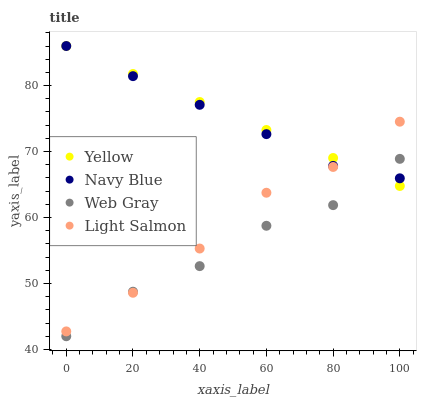Does Web Gray have the minimum area under the curve?
Answer yes or no. Yes. Does Yellow have the maximum area under the curve?
Answer yes or no. Yes. Does Light Salmon have the minimum area under the curve?
Answer yes or no. No. Does Light Salmon have the maximum area under the curve?
Answer yes or no. No. Is Yellow the smoothest?
Answer yes or no. Yes. Is Web Gray the roughest?
Answer yes or no. Yes. Is Light Salmon the smoothest?
Answer yes or no. No. Is Light Salmon the roughest?
Answer yes or no. No. Does Web Gray have the lowest value?
Answer yes or no. Yes. Does Light Salmon have the lowest value?
Answer yes or no. No. Does Yellow have the highest value?
Answer yes or no. Yes. Does Light Salmon have the highest value?
Answer yes or no. No. Does Light Salmon intersect Web Gray?
Answer yes or no. Yes. Is Light Salmon less than Web Gray?
Answer yes or no. No. Is Light Salmon greater than Web Gray?
Answer yes or no. No. 